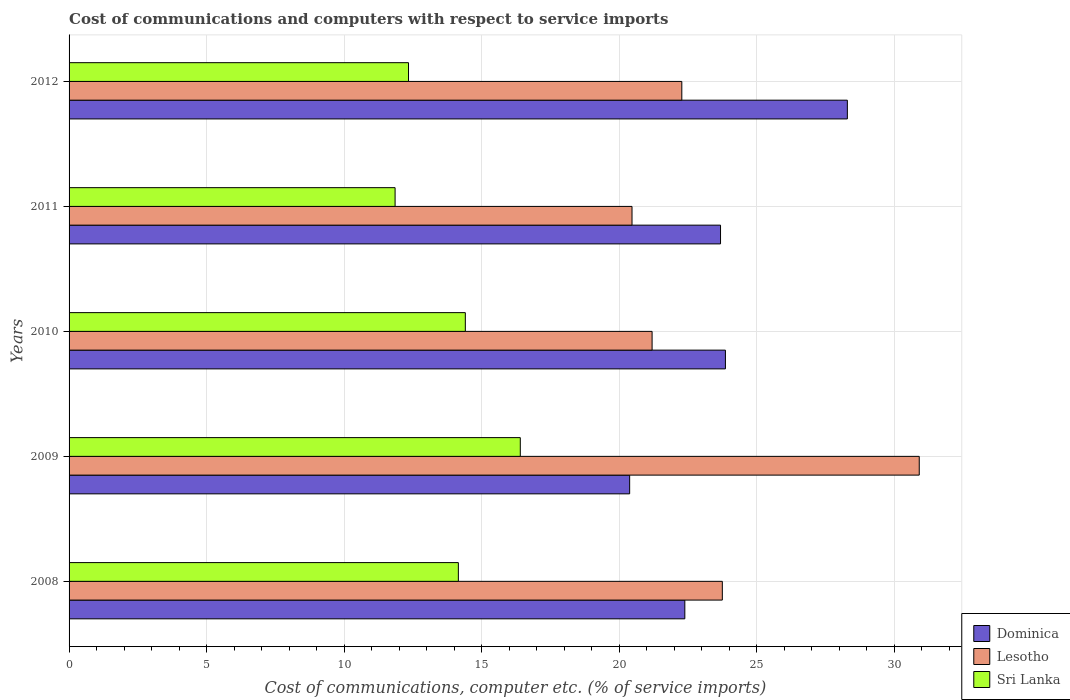How many groups of bars are there?
Give a very brief answer. 5. How many bars are there on the 1st tick from the top?
Your answer should be very brief. 3. How many bars are there on the 3rd tick from the bottom?
Provide a short and direct response. 3. What is the label of the 5th group of bars from the top?
Offer a very short reply. 2008. In how many cases, is the number of bars for a given year not equal to the number of legend labels?
Ensure brevity in your answer.  0. What is the cost of communications and computers in Dominica in 2011?
Give a very brief answer. 23.68. Across all years, what is the maximum cost of communications and computers in Sri Lanka?
Your answer should be very brief. 16.4. Across all years, what is the minimum cost of communications and computers in Dominica?
Your answer should be compact. 20.38. In which year was the cost of communications and computers in Dominica maximum?
Your answer should be very brief. 2012. What is the total cost of communications and computers in Dominica in the graph?
Your answer should be very brief. 118.58. What is the difference between the cost of communications and computers in Dominica in 2010 and that in 2011?
Offer a very short reply. 0.18. What is the difference between the cost of communications and computers in Sri Lanka in 2008 and the cost of communications and computers in Lesotho in 2012?
Provide a succinct answer. -8.12. What is the average cost of communications and computers in Dominica per year?
Keep it short and to the point. 23.72. In the year 2012, what is the difference between the cost of communications and computers in Dominica and cost of communications and computers in Sri Lanka?
Provide a succinct answer. 15.95. What is the ratio of the cost of communications and computers in Dominica in 2009 to that in 2011?
Ensure brevity in your answer.  0.86. Is the cost of communications and computers in Lesotho in 2008 less than that in 2010?
Your answer should be compact. No. What is the difference between the highest and the second highest cost of communications and computers in Sri Lanka?
Provide a succinct answer. 2. What is the difference between the highest and the lowest cost of communications and computers in Dominica?
Offer a terse response. 7.91. In how many years, is the cost of communications and computers in Dominica greater than the average cost of communications and computers in Dominica taken over all years?
Ensure brevity in your answer.  2. Is the sum of the cost of communications and computers in Lesotho in 2010 and 2012 greater than the maximum cost of communications and computers in Dominica across all years?
Your response must be concise. Yes. What does the 3rd bar from the top in 2009 represents?
Keep it short and to the point. Dominica. What does the 2nd bar from the bottom in 2012 represents?
Ensure brevity in your answer.  Lesotho. Is it the case that in every year, the sum of the cost of communications and computers in Sri Lanka and cost of communications and computers in Dominica is greater than the cost of communications and computers in Lesotho?
Keep it short and to the point. Yes. How many years are there in the graph?
Give a very brief answer. 5. What is the difference between two consecutive major ticks on the X-axis?
Your answer should be very brief. 5. Are the values on the major ticks of X-axis written in scientific E-notation?
Ensure brevity in your answer.  No. Does the graph contain any zero values?
Offer a terse response. No. Does the graph contain grids?
Give a very brief answer. Yes. How many legend labels are there?
Give a very brief answer. 3. What is the title of the graph?
Keep it short and to the point. Cost of communications and computers with respect to service imports. What is the label or title of the X-axis?
Your response must be concise. Cost of communications, computer etc. (% of service imports). What is the Cost of communications, computer etc. (% of service imports) of Dominica in 2008?
Ensure brevity in your answer.  22.38. What is the Cost of communications, computer etc. (% of service imports) of Lesotho in 2008?
Your answer should be very brief. 23.74. What is the Cost of communications, computer etc. (% of service imports) in Sri Lanka in 2008?
Give a very brief answer. 14.15. What is the Cost of communications, computer etc. (% of service imports) in Dominica in 2009?
Offer a terse response. 20.38. What is the Cost of communications, computer etc. (% of service imports) of Lesotho in 2009?
Offer a terse response. 30.9. What is the Cost of communications, computer etc. (% of service imports) of Sri Lanka in 2009?
Give a very brief answer. 16.4. What is the Cost of communications, computer etc. (% of service imports) of Dominica in 2010?
Ensure brevity in your answer.  23.86. What is the Cost of communications, computer etc. (% of service imports) of Lesotho in 2010?
Ensure brevity in your answer.  21.19. What is the Cost of communications, computer etc. (% of service imports) of Sri Lanka in 2010?
Ensure brevity in your answer.  14.4. What is the Cost of communications, computer etc. (% of service imports) of Dominica in 2011?
Give a very brief answer. 23.68. What is the Cost of communications, computer etc. (% of service imports) in Lesotho in 2011?
Provide a succinct answer. 20.46. What is the Cost of communications, computer etc. (% of service imports) in Sri Lanka in 2011?
Provide a succinct answer. 11.85. What is the Cost of communications, computer etc. (% of service imports) in Dominica in 2012?
Offer a very short reply. 28.29. What is the Cost of communications, computer etc. (% of service imports) of Lesotho in 2012?
Provide a short and direct response. 22.27. What is the Cost of communications, computer etc. (% of service imports) of Sri Lanka in 2012?
Keep it short and to the point. 12.34. Across all years, what is the maximum Cost of communications, computer etc. (% of service imports) of Dominica?
Give a very brief answer. 28.29. Across all years, what is the maximum Cost of communications, computer etc. (% of service imports) in Lesotho?
Make the answer very short. 30.9. Across all years, what is the maximum Cost of communications, computer etc. (% of service imports) of Sri Lanka?
Your response must be concise. 16.4. Across all years, what is the minimum Cost of communications, computer etc. (% of service imports) of Dominica?
Your answer should be compact. 20.38. Across all years, what is the minimum Cost of communications, computer etc. (% of service imports) in Lesotho?
Provide a succinct answer. 20.46. Across all years, what is the minimum Cost of communications, computer etc. (% of service imports) in Sri Lanka?
Keep it short and to the point. 11.85. What is the total Cost of communications, computer etc. (% of service imports) in Dominica in the graph?
Ensure brevity in your answer.  118.58. What is the total Cost of communications, computer etc. (% of service imports) of Lesotho in the graph?
Offer a very short reply. 118.57. What is the total Cost of communications, computer etc. (% of service imports) of Sri Lanka in the graph?
Provide a short and direct response. 69.14. What is the difference between the Cost of communications, computer etc. (% of service imports) in Dominica in 2008 and that in 2009?
Give a very brief answer. 2.01. What is the difference between the Cost of communications, computer etc. (% of service imports) of Lesotho in 2008 and that in 2009?
Give a very brief answer. -7.16. What is the difference between the Cost of communications, computer etc. (% of service imports) of Sri Lanka in 2008 and that in 2009?
Ensure brevity in your answer.  -2.25. What is the difference between the Cost of communications, computer etc. (% of service imports) of Dominica in 2008 and that in 2010?
Keep it short and to the point. -1.48. What is the difference between the Cost of communications, computer etc. (% of service imports) in Lesotho in 2008 and that in 2010?
Your response must be concise. 2.55. What is the difference between the Cost of communications, computer etc. (% of service imports) in Sri Lanka in 2008 and that in 2010?
Offer a terse response. -0.25. What is the difference between the Cost of communications, computer etc. (% of service imports) in Dominica in 2008 and that in 2011?
Offer a very short reply. -1.3. What is the difference between the Cost of communications, computer etc. (% of service imports) of Lesotho in 2008 and that in 2011?
Give a very brief answer. 3.28. What is the difference between the Cost of communications, computer etc. (% of service imports) of Sri Lanka in 2008 and that in 2011?
Make the answer very short. 2.3. What is the difference between the Cost of communications, computer etc. (% of service imports) in Dominica in 2008 and that in 2012?
Offer a terse response. -5.91. What is the difference between the Cost of communications, computer etc. (% of service imports) of Lesotho in 2008 and that in 2012?
Make the answer very short. 1.47. What is the difference between the Cost of communications, computer etc. (% of service imports) of Sri Lanka in 2008 and that in 2012?
Keep it short and to the point. 1.81. What is the difference between the Cost of communications, computer etc. (% of service imports) in Dominica in 2009 and that in 2010?
Make the answer very short. -3.48. What is the difference between the Cost of communications, computer etc. (% of service imports) in Lesotho in 2009 and that in 2010?
Offer a very short reply. 9.71. What is the difference between the Cost of communications, computer etc. (% of service imports) in Sri Lanka in 2009 and that in 2010?
Provide a short and direct response. 2. What is the difference between the Cost of communications, computer etc. (% of service imports) in Dominica in 2009 and that in 2011?
Provide a succinct answer. -3.3. What is the difference between the Cost of communications, computer etc. (% of service imports) in Lesotho in 2009 and that in 2011?
Ensure brevity in your answer.  10.44. What is the difference between the Cost of communications, computer etc. (% of service imports) in Sri Lanka in 2009 and that in 2011?
Provide a short and direct response. 4.55. What is the difference between the Cost of communications, computer etc. (% of service imports) in Dominica in 2009 and that in 2012?
Your answer should be very brief. -7.91. What is the difference between the Cost of communications, computer etc. (% of service imports) in Lesotho in 2009 and that in 2012?
Offer a terse response. 8.63. What is the difference between the Cost of communications, computer etc. (% of service imports) in Sri Lanka in 2009 and that in 2012?
Provide a succinct answer. 4.06. What is the difference between the Cost of communications, computer etc. (% of service imports) in Dominica in 2010 and that in 2011?
Your answer should be very brief. 0.18. What is the difference between the Cost of communications, computer etc. (% of service imports) of Lesotho in 2010 and that in 2011?
Give a very brief answer. 0.73. What is the difference between the Cost of communications, computer etc. (% of service imports) in Sri Lanka in 2010 and that in 2011?
Offer a very short reply. 2.55. What is the difference between the Cost of communications, computer etc. (% of service imports) in Dominica in 2010 and that in 2012?
Provide a succinct answer. -4.43. What is the difference between the Cost of communications, computer etc. (% of service imports) in Lesotho in 2010 and that in 2012?
Ensure brevity in your answer.  -1.08. What is the difference between the Cost of communications, computer etc. (% of service imports) in Sri Lanka in 2010 and that in 2012?
Offer a very short reply. 2.06. What is the difference between the Cost of communications, computer etc. (% of service imports) in Dominica in 2011 and that in 2012?
Offer a terse response. -4.61. What is the difference between the Cost of communications, computer etc. (% of service imports) of Lesotho in 2011 and that in 2012?
Provide a short and direct response. -1.81. What is the difference between the Cost of communications, computer etc. (% of service imports) in Sri Lanka in 2011 and that in 2012?
Your answer should be very brief. -0.49. What is the difference between the Cost of communications, computer etc. (% of service imports) of Dominica in 2008 and the Cost of communications, computer etc. (% of service imports) of Lesotho in 2009?
Offer a very short reply. -8.52. What is the difference between the Cost of communications, computer etc. (% of service imports) in Dominica in 2008 and the Cost of communications, computer etc. (% of service imports) in Sri Lanka in 2009?
Your response must be concise. 5.98. What is the difference between the Cost of communications, computer etc. (% of service imports) of Lesotho in 2008 and the Cost of communications, computer etc. (% of service imports) of Sri Lanka in 2009?
Offer a very short reply. 7.34. What is the difference between the Cost of communications, computer etc. (% of service imports) in Dominica in 2008 and the Cost of communications, computer etc. (% of service imports) in Lesotho in 2010?
Your response must be concise. 1.19. What is the difference between the Cost of communications, computer etc. (% of service imports) in Dominica in 2008 and the Cost of communications, computer etc. (% of service imports) in Sri Lanka in 2010?
Offer a very short reply. 7.98. What is the difference between the Cost of communications, computer etc. (% of service imports) of Lesotho in 2008 and the Cost of communications, computer etc. (% of service imports) of Sri Lanka in 2010?
Keep it short and to the point. 9.34. What is the difference between the Cost of communications, computer etc. (% of service imports) in Dominica in 2008 and the Cost of communications, computer etc. (% of service imports) in Lesotho in 2011?
Keep it short and to the point. 1.92. What is the difference between the Cost of communications, computer etc. (% of service imports) in Dominica in 2008 and the Cost of communications, computer etc. (% of service imports) in Sri Lanka in 2011?
Provide a succinct answer. 10.53. What is the difference between the Cost of communications, computer etc. (% of service imports) of Lesotho in 2008 and the Cost of communications, computer etc. (% of service imports) of Sri Lanka in 2011?
Provide a short and direct response. 11.89. What is the difference between the Cost of communications, computer etc. (% of service imports) in Dominica in 2008 and the Cost of communications, computer etc. (% of service imports) in Lesotho in 2012?
Your response must be concise. 0.11. What is the difference between the Cost of communications, computer etc. (% of service imports) of Dominica in 2008 and the Cost of communications, computer etc. (% of service imports) of Sri Lanka in 2012?
Offer a terse response. 10.04. What is the difference between the Cost of communications, computer etc. (% of service imports) of Lesotho in 2008 and the Cost of communications, computer etc. (% of service imports) of Sri Lanka in 2012?
Your answer should be compact. 11.41. What is the difference between the Cost of communications, computer etc. (% of service imports) in Dominica in 2009 and the Cost of communications, computer etc. (% of service imports) in Lesotho in 2010?
Provide a succinct answer. -0.82. What is the difference between the Cost of communications, computer etc. (% of service imports) in Dominica in 2009 and the Cost of communications, computer etc. (% of service imports) in Sri Lanka in 2010?
Make the answer very short. 5.97. What is the difference between the Cost of communications, computer etc. (% of service imports) in Lesotho in 2009 and the Cost of communications, computer etc. (% of service imports) in Sri Lanka in 2010?
Your response must be concise. 16.5. What is the difference between the Cost of communications, computer etc. (% of service imports) in Dominica in 2009 and the Cost of communications, computer etc. (% of service imports) in Lesotho in 2011?
Keep it short and to the point. -0.09. What is the difference between the Cost of communications, computer etc. (% of service imports) in Dominica in 2009 and the Cost of communications, computer etc. (% of service imports) in Sri Lanka in 2011?
Provide a succinct answer. 8.53. What is the difference between the Cost of communications, computer etc. (% of service imports) in Lesotho in 2009 and the Cost of communications, computer etc. (% of service imports) in Sri Lanka in 2011?
Keep it short and to the point. 19.05. What is the difference between the Cost of communications, computer etc. (% of service imports) of Dominica in 2009 and the Cost of communications, computer etc. (% of service imports) of Lesotho in 2012?
Give a very brief answer. -1.9. What is the difference between the Cost of communications, computer etc. (% of service imports) in Dominica in 2009 and the Cost of communications, computer etc. (% of service imports) in Sri Lanka in 2012?
Provide a succinct answer. 8.04. What is the difference between the Cost of communications, computer etc. (% of service imports) of Lesotho in 2009 and the Cost of communications, computer etc. (% of service imports) of Sri Lanka in 2012?
Offer a terse response. 18.56. What is the difference between the Cost of communications, computer etc. (% of service imports) of Dominica in 2010 and the Cost of communications, computer etc. (% of service imports) of Lesotho in 2011?
Offer a very short reply. 3.4. What is the difference between the Cost of communications, computer etc. (% of service imports) in Dominica in 2010 and the Cost of communications, computer etc. (% of service imports) in Sri Lanka in 2011?
Provide a short and direct response. 12.01. What is the difference between the Cost of communications, computer etc. (% of service imports) of Lesotho in 2010 and the Cost of communications, computer etc. (% of service imports) of Sri Lanka in 2011?
Ensure brevity in your answer.  9.34. What is the difference between the Cost of communications, computer etc. (% of service imports) of Dominica in 2010 and the Cost of communications, computer etc. (% of service imports) of Lesotho in 2012?
Offer a very short reply. 1.59. What is the difference between the Cost of communications, computer etc. (% of service imports) of Dominica in 2010 and the Cost of communications, computer etc. (% of service imports) of Sri Lanka in 2012?
Offer a very short reply. 11.52. What is the difference between the Cost of communications, computer etc. (% of service imports) in Lesotho in 2010 and the Cost of communications, computer etc. (% of service imports) in Sri Lanka in 2012?
Offer a very short reply. 8.85. What is the difference between the Cost of communications, computer etc. (% of service imports) of Dominica in 2011 and the Cost of communications, computer etc. (% of service imports) of Lesotho in 2012?
Offer a terse response. 1.41. What is the difference between the Cost of communications, computer etc. (% of service imports) in Dominica in 2011 and the Cost of communications, computer etc. (% of service imports) in Sri Lanka in 2012?
Make the answer very short. 11.34. What is the difference between the Cost of communications, computer etc. (% of service imports) of Lesotho in 2011 and the Cost of communications, computer etc. (% of service imports) of Sri Lanka in 2012?
Provide a short and direct response. 8.12. What is the average Cost of communications, computer etc. (% of service imports) of Dominica per year?
Provide a succinct answer. 23.72. What is the average Cost of communications, computer etc. (% of service imports) in Lesotho per year?
Your response must be concise. 23.71. What is the average Cost of communications, computer etc. (% of service imports) in Sri Lanka per year?
Your answer should be compact. 13.83. In the year 2008, what is the difference between the Cost of communications, computer etc. (% of service imports) in Dominica and Cost of communications, computer etc. (% of service imports) in Lesotho?
Keep it short and to the point. -1.36. In the year 2008, what is the difference between the Cost of communications, computer etc. (% of service imports) of Dominica and Cost of communications, computer etc. (% of service imports) of Sri Lanka?
Provide a short and direct response. 8.23. In the year 2008, what is the difference between the Cost of communications, computer etc. (% of service imports) of Lesotho and Cost of communications, computer etc. (% of service imports) of Sri Lanka?
Make the answer very short. 9.59. In the year 2009, what is the difference between the Cost of communications, computer etc. (% of service imports) in Dominica and Cost of communications, computer etc. (% of service imports) in Lesotho?
Offer a terse response. -10.53. In the year 2009, what is the difference between the Cost of communications, computer etc. (% of service imports) in Dominica and Cost of communications, computer etc. (% of service imports) in Sri Lanka?
Give a very brief answer. 3.98. In the year 2009, what is the difference between the Cost of communications, computer etc. (% of service imports) in Lesotho and Cost of communications, computer etc. (% of service imports) in Sri Lanka?
Ensure brevity in your answer.  14.5. In the year 2010, what is the difference between the Cost of communications, computer etc. (% of service imports) in Dominica and Cost of communications, computer etc. (% of service imports) in Lesotho?
Offer a terse response. 2.67. In the year 2010, what is the difference between the Cost of communications, computer etc. (% of service imports) in Dominica and Cost of communications, computer etc. (% of service imports) in Sri Lanka?
Your answer should be very brief. 9.45. In the year 2010, what is the difference between the Cost of communications, computer etc. (% of service imports) in Lesotho and Cost of communications, computer etc. (% of service imports) in Sri Lanka?
Provide a succinct answer. 6.79. In the year 2011, what is the difference between the Cost of communications, computer etc. (% of service imports) of Dominica and Cost of communications, computer etc. (% of service imports) of Lesotho?
Ensure brevity in your answer.  3.22. In the year 2011, what is the difference between the Cost of communications, computer etc. (% of service imports) in Dominica and Cost of communications, computer etc. (% of service imports) in Sri Lanka?
Provide a succinct answer. 11.83. In the year 2011, what is the difference between the Cost of communications, computer etc. (% of service imports) in Lesotho and Cost of communications, computer etc. (% of service imports) in Sri Lanka?
Give a very brief answer. 8.61. In the year 2012, what is the difference between the Cost of communications, computer etc. (% of service imports) in Dominica and Cost of communications, computer etc. (% of service imports) in Lesotho?
Make the answer very short. 6.02. In the year 2012, what is the difference between the Cost of communications, computer etc. (% of service imports) in Dominica and Cost of communications, computer etc. (% of service imports) in Sri Lanka?
Ensure brevity in your answer.  15.95. In the year 2012, what is the difference between the Cost of communications, computer etc. (% of service imports) in Lesotho and Cost of communications, computer etc. (% of service imports) in Sri Lanka?
Give a very brief answer. 9.93. What is the ratio of the Cost of communications, computer etc. (% of service imports) of Dominica in 2008 to that in 2009?
Give a very brief answer. 1.1. What is the ratio of the Cost of communications, computer etc. (% of service imports) in Lesotho in 2008 to that in 2009?
Offer a terse response. 0.77. What is the ratio of the Cost of communications, computer etc. (% of service imports) in Sri Lanka in 2008 to that in 2009?
Provide a short and direct response. 0.86. What is the ratio of the Cost of communications, computer etc. (% of service imports) in Dominica in 2008 to that in 2010?
Keep it short and to the point. 0.94. What is the ratio of the Cost of communications, computer etc. (% of service imports) in Lesotho in 2008 to that in 2010?
Ensure brevity in your answer.  1.12. What is the ratio of the Cost of communications, computer etc. (% of service imports) in Sri Lanka in 2008 to that in 2010?
Make the answer very short. 0.98. What is the ratio of the Cost of communications, computer etc. (% of service imports) of Dominica in 2008 to that in 2011?
Keep it short and to the point. 0.95. What is the ratio of the Cost of communications, computer etc. (% of service imports) in Lesotho in 2008 to that in 2011?
Provide a succinct answer. 1.16. What is the ratio of the Cost of communications, computer etc. (% of service imports) of Sri Lanka in 2008 to that in 2011?
Your answer should be very brief. 1.19. What is the ratio of the Cost of communications, computer etc. (% of service imports) in Dominica in 2008 to that in 2012?
Offer a very short reply. 0.79. What is the ratio of the Cost of communications, computer etc. (% of service imports) in Lesotho in 2008 to that in 2012?
Provide a short and direct response. 1.07. What is the ratio of the Cost of communications, computer etc. (% of service imports) of Sri Lanka in 2008 to that in 2012?
Your answer should be compact. 1.15. What is the ratio of the Cost of communications, computer etc. (% of service imports) in Dominica in 2009 to that in 2010?
Offer a terse response. 0.85. What is the ratio of the Cost of communications, computer etc. (% of service imports) in Lesotho in 2009 to that in 2010?
Offer a terse response. 1.46. What is the ratio of the Cost of communications, computer etc. (% of service imports) in Sri Lanka in 2009 to that in 2010?
Your answer should be compact. 1.14. What is the ratio of the Cost of communications, computer etc. (% of service imports) in Dominica in 2009 to that in 2011?
Provide a succinct answer. 0.86. What is the ratio of the Cost of communications, computer etc. (% of service imports) of Lesotho in 2009 to that in 2011?
Provide a succinct answer. 1.51. What is the ratio of the Cost of communications, computer etc. (% of service imports) of Sri Lanka in 2009 to that in 2011?
Give a very brief answer. 1.38. What is the ratio of the Cost of communications, computer etc. (% of service imports) in Dominica in 2009 to that in 2012?
Your answer should be very brief. 0.72. What is the ratio of the Cost of communications, computer etc. (% of service imports) in Lesotho in 2009 to that in 2012?
Make the answer very short. 1.39. What is the ratio of the Cost of communications, computer etc. (% of service imports) of Sri Lanka in 2009 to that in 2012?
Give a very brief answer. 1.33. What is the ratio of the Cost of communications, computer etc. (% of service imports) in Dominica in 2010 to that in 2011?
Offer a very short reply. 1.01. What is the ratio of the Cost of communications, computer etc. (% of service imports) in Lesotho in 2010 to that in 2011?
Provide a succinct answer. 1.04. What is the ratio of the Cost of communications, computer etc. (% of service imports) in Sri Lanka in 2010 to that in 2011?
Ensure brevity in your answer.  1.22. What is the ratio of the Cost of communications, computer etc. (% of service imports) of Dominica in 2010 to that in 2012?
Give a very brief answer. 0.84. What is the ratio of the Cost of communications, computer etc. (% of service imports) of Lesotho in 2010 to that in 2012?
Give a very brief answer. 0.95. What is the ratio of the Cost of communications, computer etc. (% of service imports) in Sri Lanka in 2010 to that in 2012?
Provide a short and direct response. 1.17. What is the ratio of the Cost of communications, computer etc. (% of service imports) in Dominica in 2011 to that in 2012?
Offer a terse response. 0.84. What is the ratio of the Cost of communications, computer etc. (% of service imports) of Lesotho in 2011 to that in 2012?
Your response must be concise. 0.92. What is the ratio of the Cost of communications, computer etc. (% of service imports) in Sri Lanka in 2011 to that in 2012?
Keep it short and to the point. 0.96. What is the difference between the highest and the second highest Cost of communications, computer etc. (% of service imports) in Dominica?
Make the answer very short. 4.43. What is the difference between the highest and the second highest Cost of communications, computer etc. (% of service imports) of Lesotho?
Provide a short and direct response. 7.16. What is the difference between the highest and the second highest Cost of communications, computer etc. (% of service imports) in Sri Lanka?
Keep it short and to the point. 2. What is the difference between the highest and the lowest Cost of communications, computer etc. (% of service imports) in Dominica?
Provide a short and direct response. 7.91. What is the difference between the highest and the lowest Cost of communications, computer etc. (% of service imports) of Lesotho?
Make the answer very short. 10.44. What is the difference between the highest and the lowest Cost of communications, computer etc. (% of service imports) of Sri Lanka?
Ensure brevity in your answer.  4.55. 